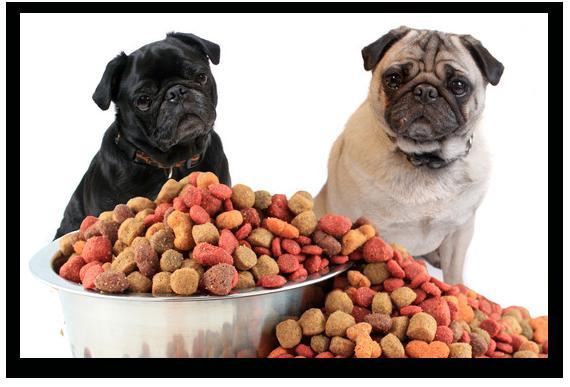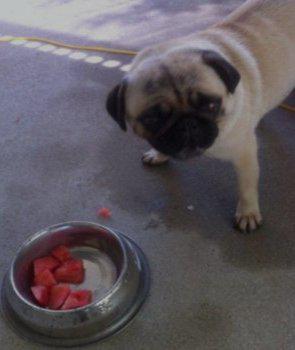The first image is the image on the left, the second image is the image on the right. For the images displayed, is the sentence "In the left image, a dog is eating some food set up for a human." factually correct? Answer yes or no. No. The first image is the image on the left, the second image is the image on the right. For the images shown, is this caption "Atleast one picture contains a bowl with food." true? Answer yes or no. Yes. 